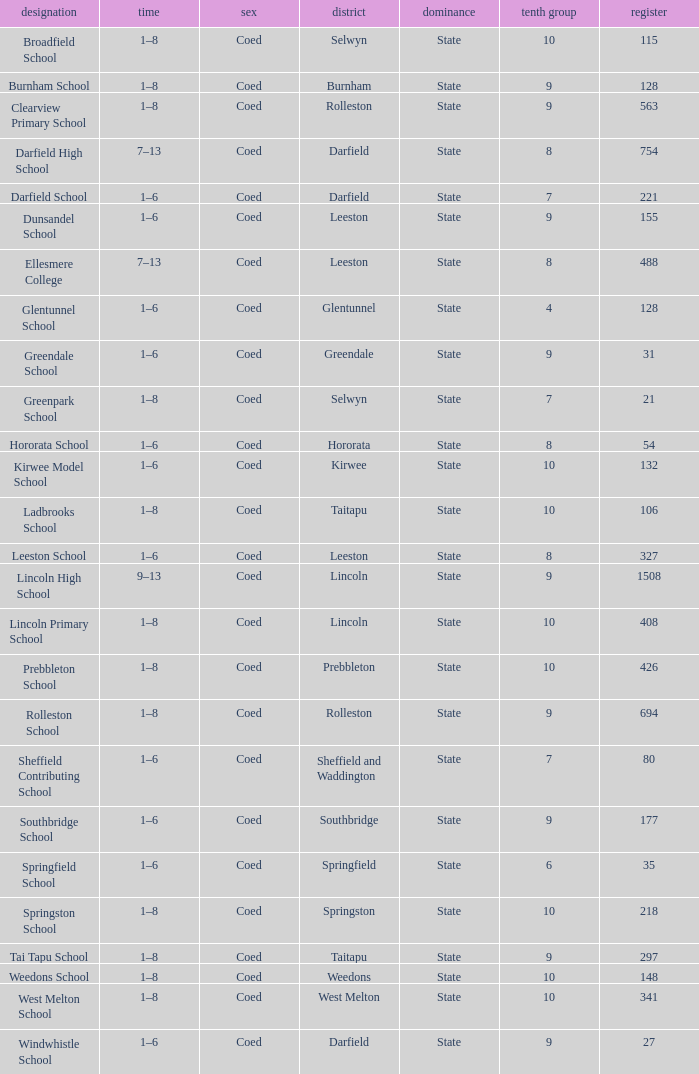Which years have a Name of ladbrooks school? 1–8. 